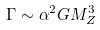Convert formula to latex. <formula><loc_0><loc_0><loc_500><loc_500>\Gamma \sim \alpha ^ { 2 } G M _ { Z } ^ { 3 }</formula> 